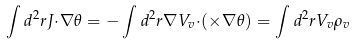<formula> <loc_0><loc_0><loc_500><loc_500>\int d ^ { 2 } r { J } { \cdot } { \nabla } \theta = - \int d ^ { 2 } r { \nabla } V _ { v } { \cdot } ( { \times } { \nabla } \theta ) = \int d ^ { 2 } r V _ { v } \rho _ { v }</formula> 